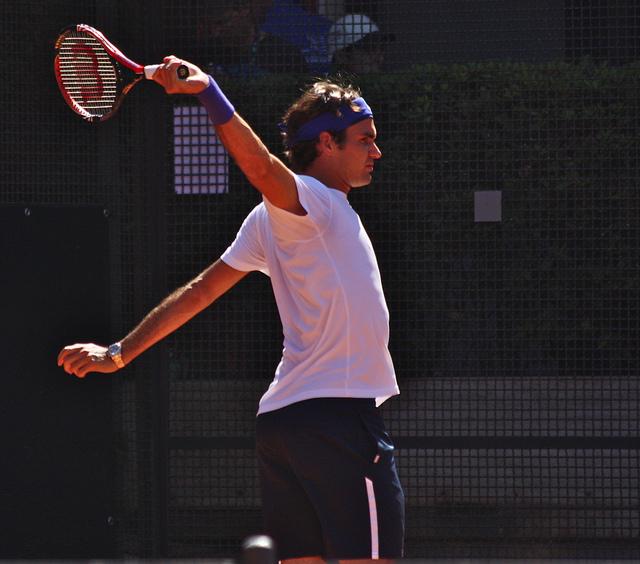Is the background in focus?
Short answer required. Yes. What is the person doing?
Keep it brief. Playing tennis. Is there a stripe on the tennis players shorts?
Give a very brief answer. Yes. What is the tennis player wearing on his head?
Quick response, please. Headband. Is this game sponsored?
Short answer required. No. Is the tennis player stretching?
Write a very short answer. Yes. 